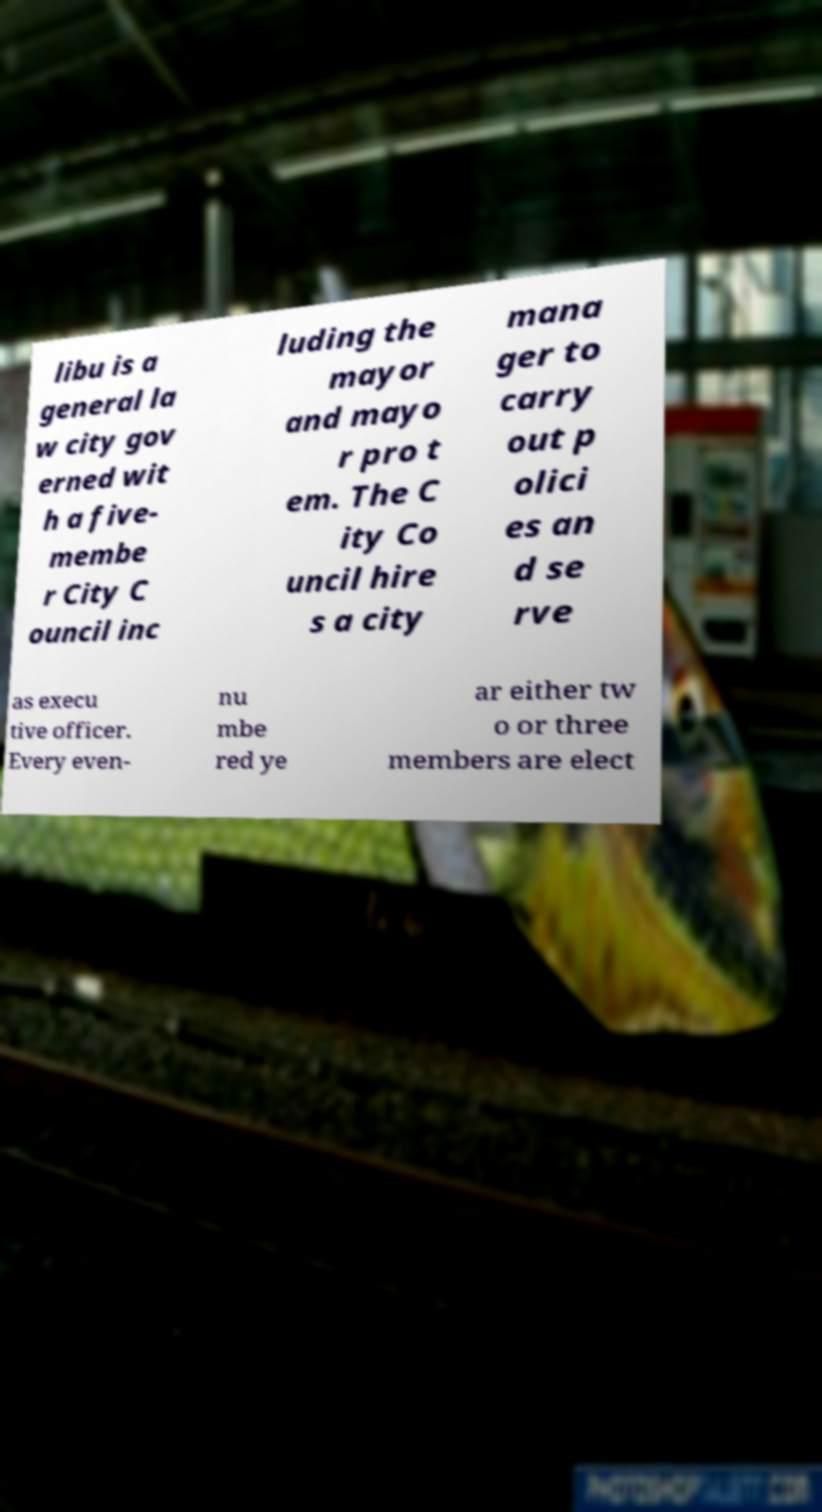Could you extract and type out the text from this image? libu is a general la w city gov erned wit h a five- membe r City C ouncil inc luding the mayor and mayo r pro t em. The C ity Co uncil hire s a city mana ger to carry out p olici es an d se rve as execu tive officer. Every even- nu mbe red ye ar either tw o or three members are elect 